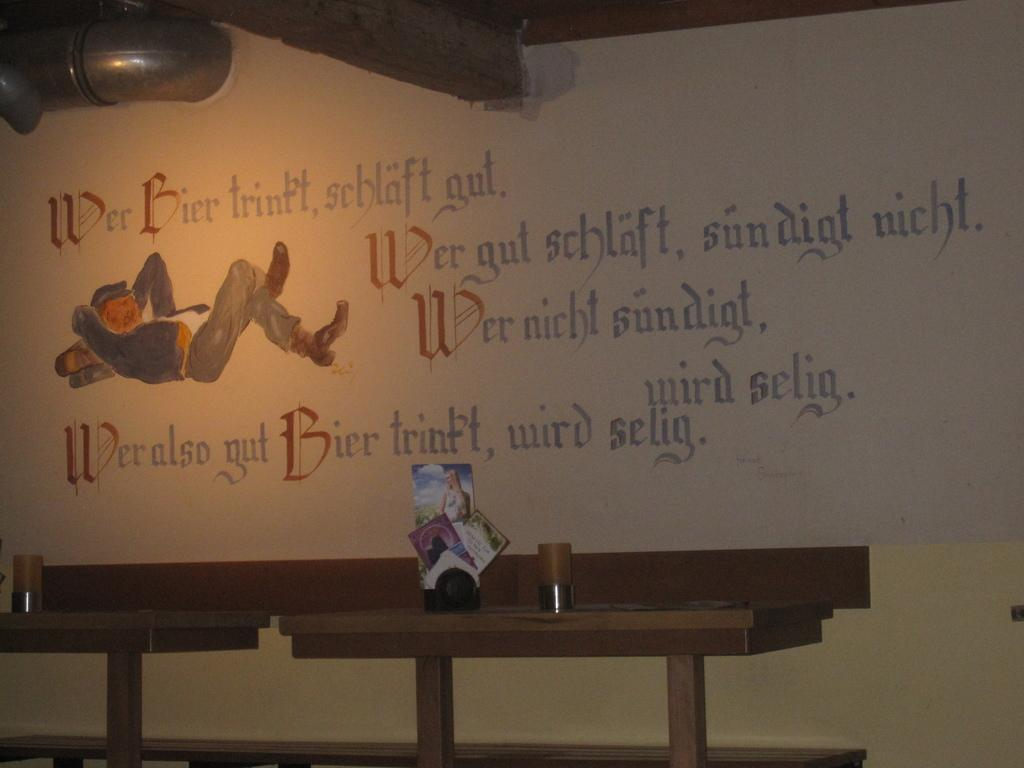<image>
Write a terse but informative summary of the picture. White wall which starts with the word "Wer". 